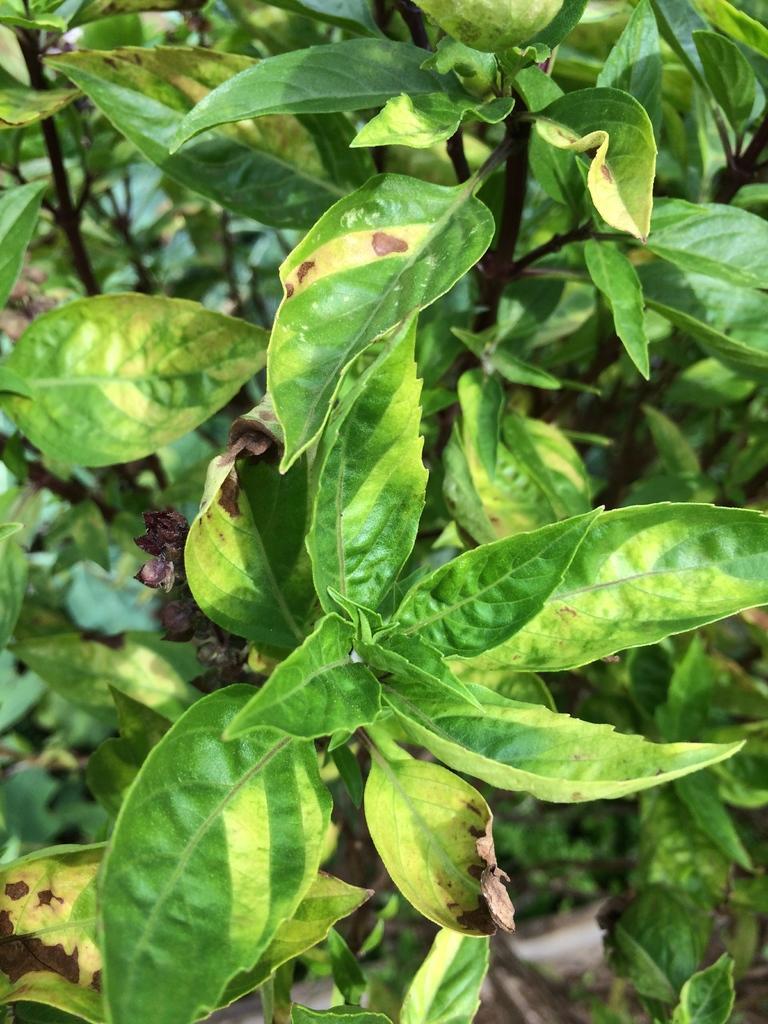Please provide a concise description of this image. In this image I can see number of green colour leaves. 